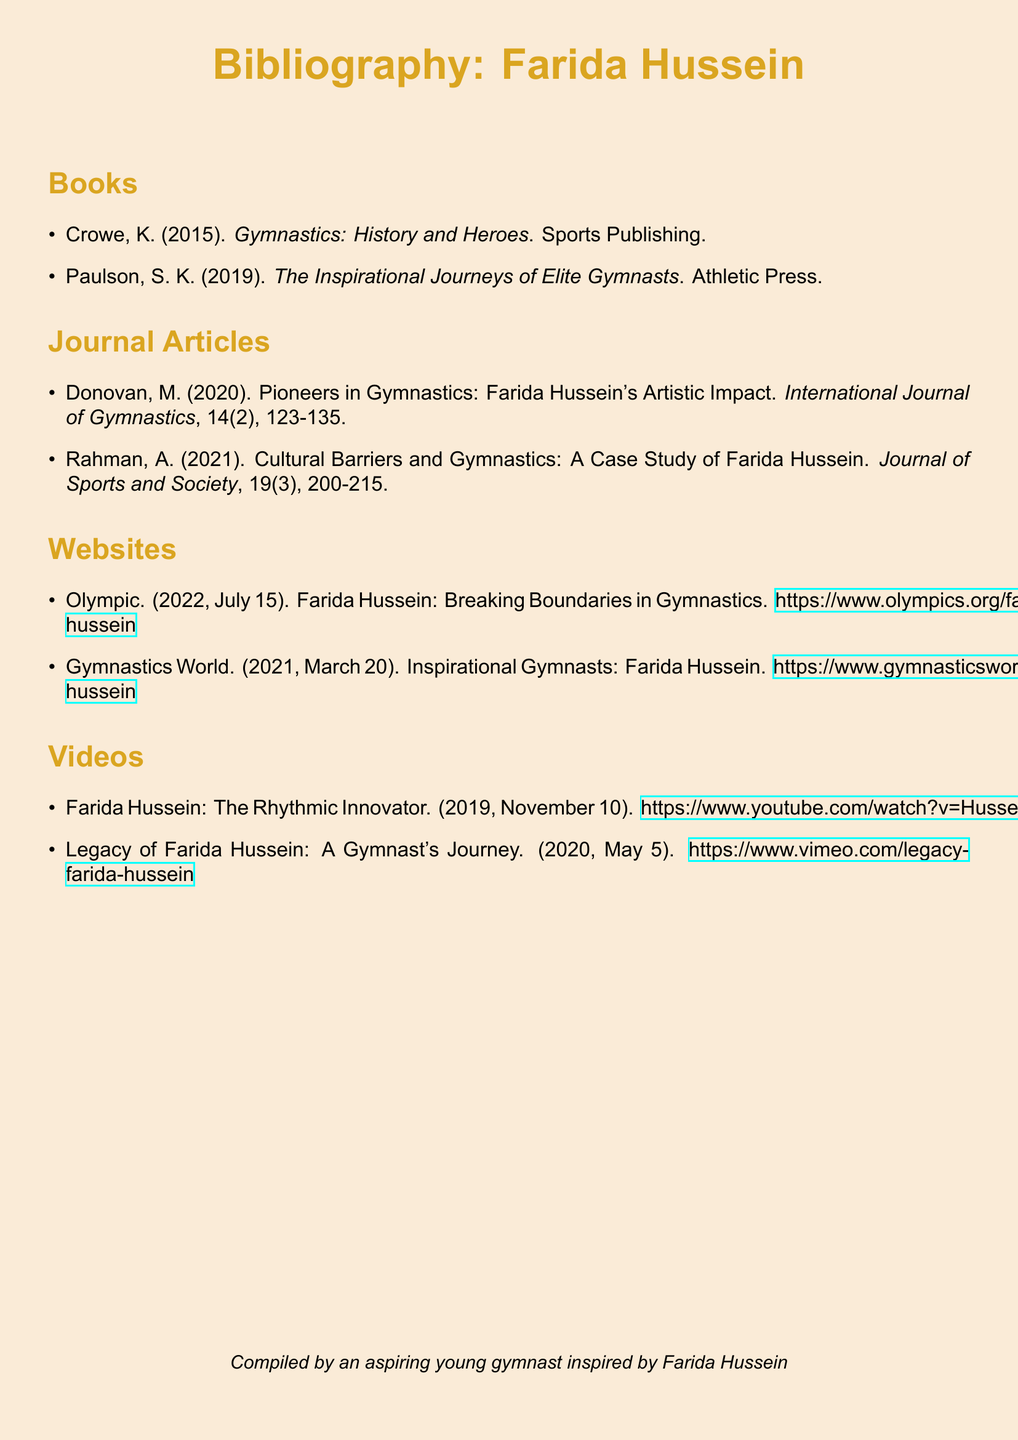What is the title of the first book listed? The first book listed in the bibliography is by K. Crowe, published in 2015.
Answer: Gymnastics: History and Heroes Who authored the article on Farida Hussein's artistic impact? The article discussing Farida Hussein's artistic impact was authored by M. Donovan in 2020.
Answer: M. Donovan What is the volume number of the 'Journal of Sports and Society' article? The article by A. Rahman in the Journal of Sports and Society is in volume 19.
Answer: 19 Which website features an article titled "Breaking Boundaries in Gymnastics"? The article titled "Breaking Boundaries in Gymnastics" is available on the Olympic website.
Answer: Olympic How many videos are listed in the bibliography? There are two videos related to Farida Hussein listed in the bibliography.
Answer: 2 What year was the article about cultural barriers published? The article by A. Rahman discussing cultural barriers was published in the year 2021.
Answer: 2021 Who compiled this bibliography? The bibliography was compiled by an aspiring young gymnast inspired by Farida Hussein.
Answer: An aspiring young gymnast inspired by Farida Hussein What color is used for the section headings in the document? The section headings are colored in a shade defined in RGB as (218,165,32).
Answer: Gymnast 